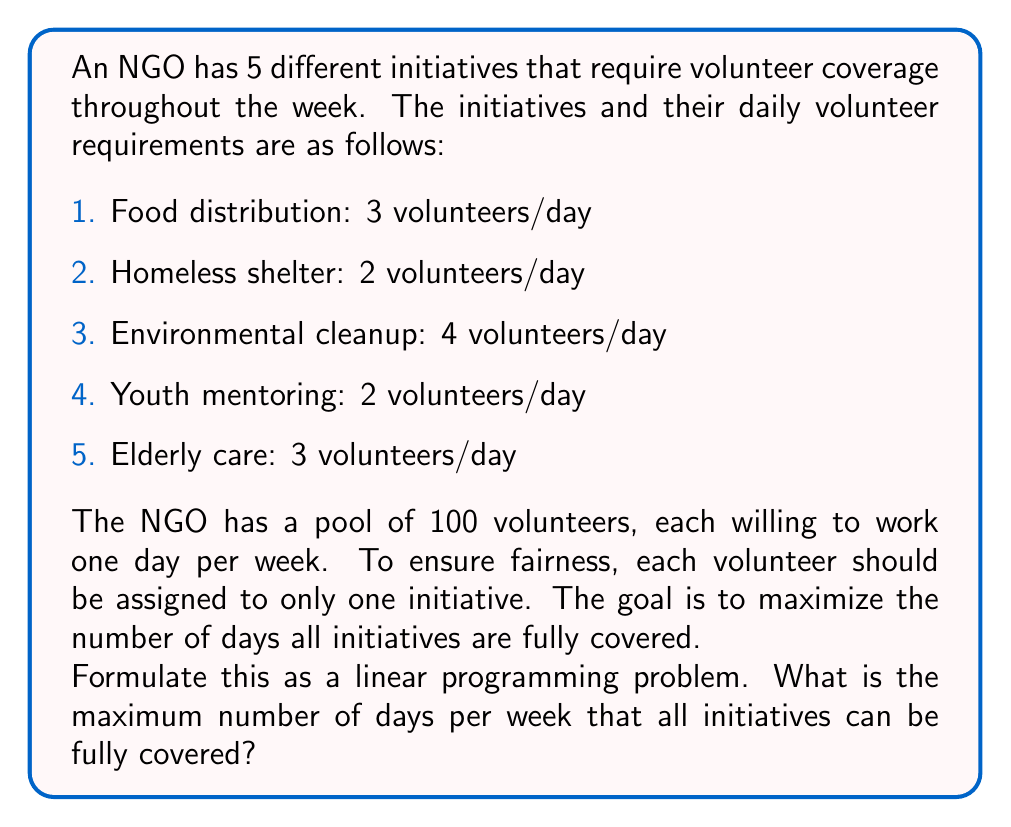Solve this math problem. To solve this problem, we need to formulate a linear programming model:

Let $x_i$ be the number of days initiative $i$ is fully covered per week.

Objective function:
Maximize $z = x_1 + x_2 + x_3 + x_4 + x_5$

Constraints:

1. Volunteer availability:
   $$3x_1 + 2x_2 + 4x_3 + 2x_4 + 3x_5 \leq 100$$

2. Days per week constraint:
   $$x_i \leq 7 \text{ for } i = 1, 2, 3, 4, 5$$

3. Non-negativity:
   $$x_i \geq 0 \text{ for } i = 1, 2, 3, 4, 5$$

To solve this, we can use the simplex method or a linear programming solver. However, we can also solve it logically:

1. The total number of volunteer-days available is 100.
2. The total number of volunteers required for one day of full coverage for all initiatives is:
   $$3 + 2 + 4 + 2 + 3 = 14$$
3. Therefore, the maximum number of days all initiatives can be fully covered is:
   $$\lfloor 100 / 14 \rfloor = 7$$

This solution satisfies all constraints:
- It uses 98 out of 100 available volunteer-days.
- No initiative exceeds 7 days of coverage per week.
- All variables are non-negative and integer.
Answer: The maximum number of days per week that all initiatives can be fully covered is 7 days. 